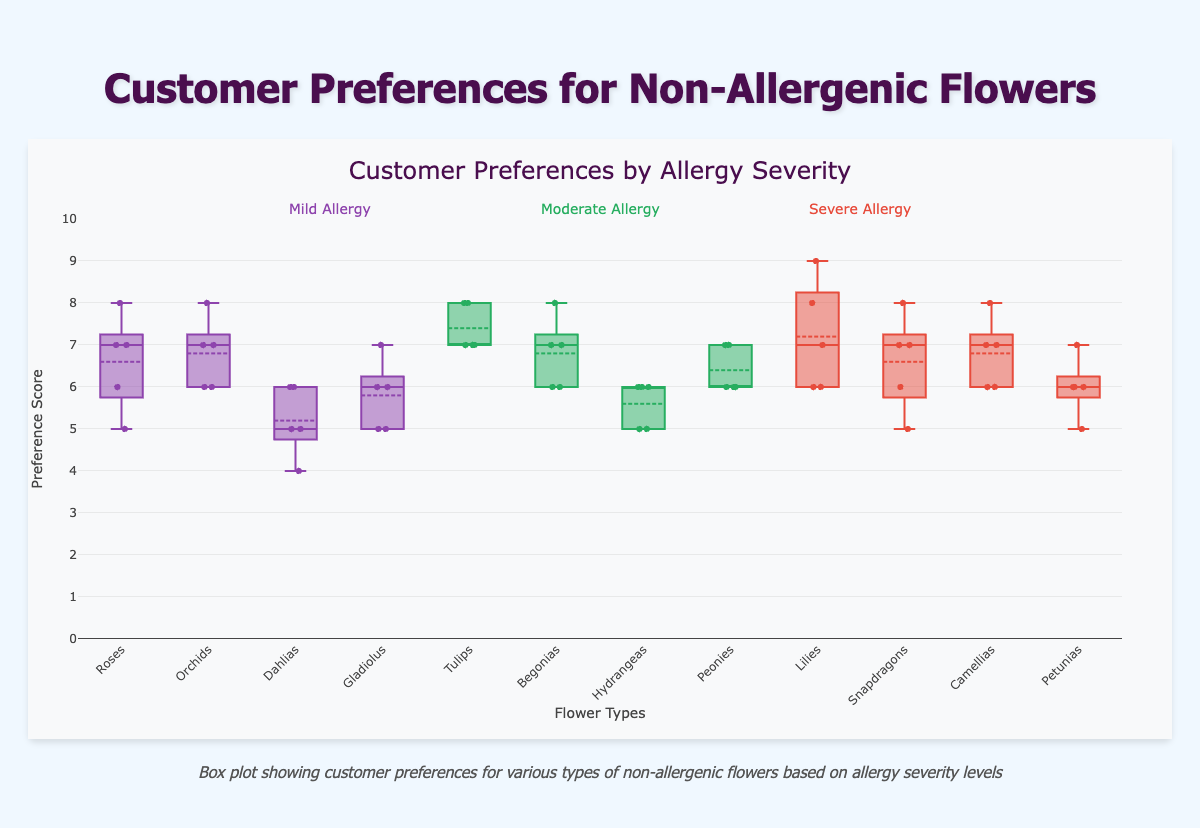What is the title of this box plot? The title is typically found at the top of the figure, it indicates the main subject of the data being visualized.
Answer: Customer Preferences by Allergy Severity Which flower type has the highest median preference in the mild allergy group? Look at the central line within each box plot which indicates the median value. Identify the highest one among the flowers belonging to the mild allergy group.
Answer: Orchids Which flower has the lowest overall preference score in the moderate allergy group? Identify the flower with the minimum value (bottom whisker) that is closest to zero within the moderate allergy group.
Answer: Hydrangeas How many data points are plotted for each flower type? Each box plot represents several data points, generally indicated by small scatter points within the figure. Count the individual points in one flower plot.
Answer: 5 Which flower in the severe allergy group shows the widest range of preferences? The range is the distance between the top and bottom whiskers. Identify the flower with the largest gap between these whiskers within the severe allergy group.
Answer: Lilies What is the median preference score for Tulips? Identify the central line within the box plot for Tulips, which represents the median value.
Answer: 7 Which flower type shows the greatest variability in preferences in the mild allergy group? Variability is represented by the length of the box and the whiskers. Look for the plot with the largest combined length of the box and whiskers within the mild allergy group.
Answer: Gladiolus Compare the interquartile range (IQR) for Roses and Lilies. Which is larger? The IQR is the range between the first quartile (bottom of the box) and the third quartile (top of the box). Measure the lengths of these ranges for both Roses and Lilies and compare them.
Answer: Lilies Which flower type in the moderate allergy group has the most similar preference distribution to Peonies? Look for the shape, median, and spread of the box plots in the moderate allergy group and identify the one which most closely matches the characteristics of Peonies.
Answer: Begonias What is the preference range for Camellias in the severe allergy group? The range is calculated from the bottom whisker to the top whisker. Identify these extremes for Camellias within the severe allergy group.
Answer: 6 to 8 